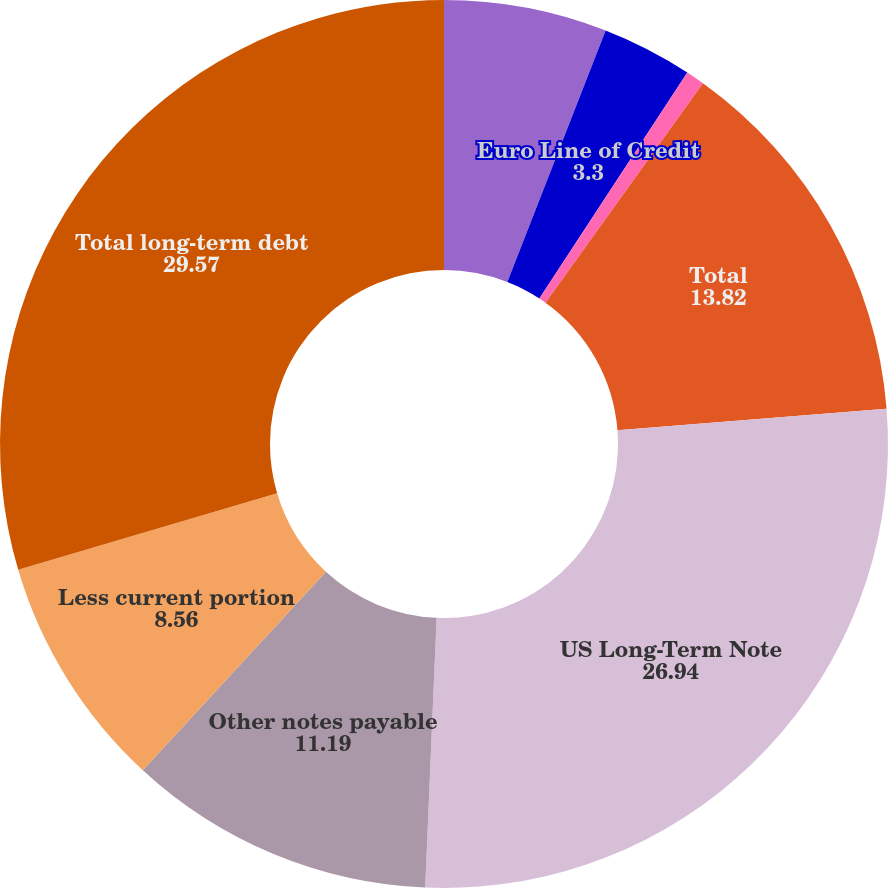Convert chart. <chart><loc_0><loc_0><loc_500><loc_500><pie_chart><fcel>Other European Facilities<fcel>Euro Line of Credit<fcel>Foreign subsidiary drawings on<fcel>Total<fcel>US Long-Term Note<fcel>Other notes payable<fcel>Less current portion<fcel>Total long-term debt<nl><fcel>5.93%<fcel>3.3%<fcel>0.68%<fcel>13.82%<fcel>26.94%<fcel>11.19%<fcel>8.56%<fcel>29.57%<nl></chart> 